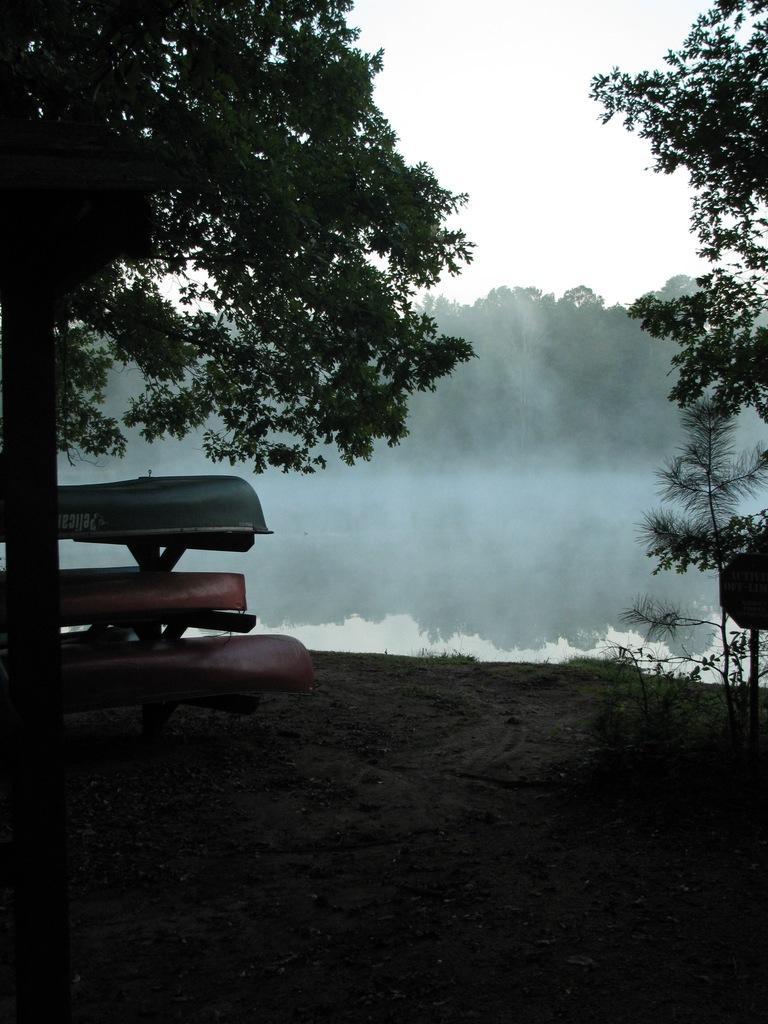Can you describe this image briefly? In this image we can see few trees, water, an object on the ground and the sky. 